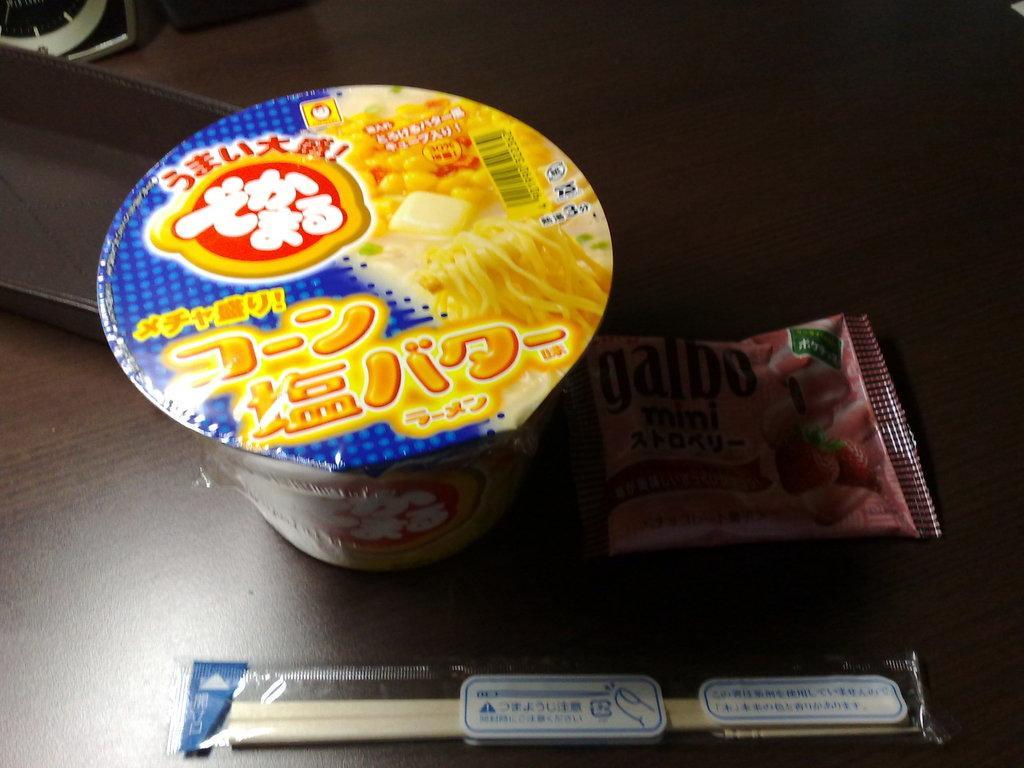Can you describe this image briefly? In this image we can see convenience food and two sticks. 